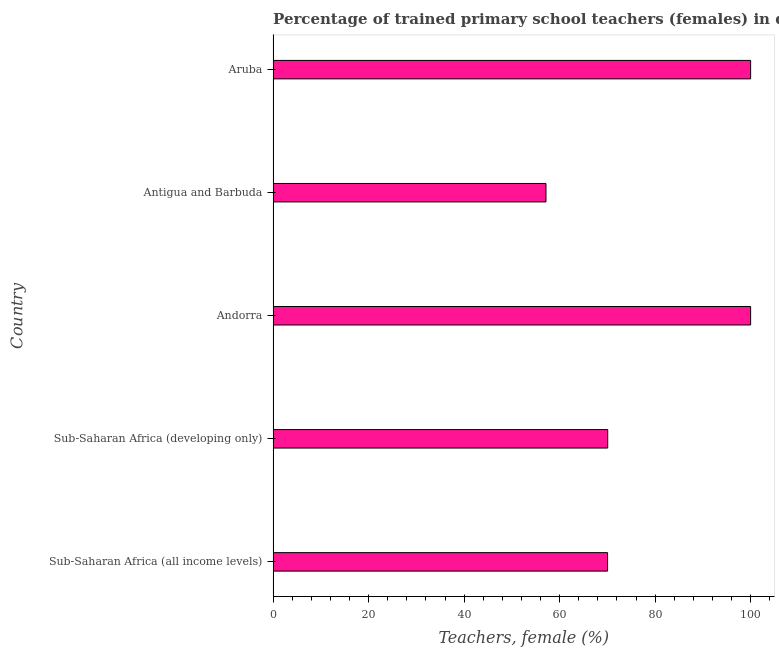Does the graph contain grids?
Provide a short and direct response. No. What is the title of the graph?
Your answer should be very brief. Percentage of trained primary school teachers (females) in different countries. What is the label or title of the X-axis?
Provide a succinct answer. Teachers, female (%). What is the percentage of trained female teachers in Aruba?
Your answer should be very brief. 100. Across all countries, what is the maximum percentage of trained female teachers?
Give a very brief answer. 100. Across all countries, what is the minimum percentage of trained female teachers?
Offer a terse response. 57.14. In which country was the percentage of trained female teachers maximum?
Your answer should be very brief. Andorra. In which country was the percentage of trained female teachers minimum?
Your answer should be compact. Antigua and Barbuda. What is the sum of the percentage of trained female teachers?
Give a very brief answer. 397.26. What is the difference between the percentage of trained female teachers in Aruba and Sub-Saharan Africa (all income levels)?
Make the answer very short. 29.95. What is the average percentage of trained female teachers per country?
Offer a terse response. 79.45. What is the median percentage of trained female teachers?
Ensure brevity in your answer.  70.07. What is the ratio of the percentage of trained female teachers in Aruba to that in Sub-Saharan Africa (all income levels)?
Your answer should be very brief. 1.43. Is the difference between the percentage of trained female teachers in Antigua and Barbuda and Sub-Saharan Africa (all income levels) greater than the difference between any two countries?
Provide a succinct answer. No. What is the difference between the highest and the lowest percentage of trained female teachers?
Your answer should be very brief. 42.86. How many countries are there in the graph?
Your answer should be very brief. 5. What is the difference between two consecutive major ticks on the X-axis?
Provide a short and direct response. 20. Are the values on the major ticks of X-axis written in scientific E-notation?
Keep it short and to the point. No. What is the Teachers, female (%) in Sub-Saharan Africa (all income levels)?
Provide a succinct answer. 70.05. What is the Teachers, female (%) in Sub-Saharan Africa (developing only)?
Your answer should be compact. 70.07. What is the Teachers, female (%) in Andorra?
Offer a terse response. 100. What is the Teachers, female (%) of Antigua and Barbuda?
Ensure brevity in your answer.  57.14. What is the Teachers, female (%) in Aruba?
Offer a very short reply. 100. What is the difference between the Teachers, female (%) in Sub-Saharan Africa (all income levels) and Sub-Saharan Africa (developing only)?
Your answer should be very brief. -0.03. What is the difference between the Teachers, female (%) in Sub-Saharan Africa (all income levels) and Andorra?
Keep it short and to the point. -29.95. What is the difference between the Teachers, female (%) in Sub-Saharan Africa (all income levels) and Antigua and Barbuda?
Give a very brief answer. 12.9. What is the difference between the Teachers, female (%) in Sub-Saharan Africa (all income levels) and Aruba?
Make the answer very short. -29.95. What is the difference between the Teachers, female (%) in Sub-Saharan Africa (developing only) and Andorra?
Give a very brief answer. -29.93. What is the difference between the Teachers, female (%) in Sub-Saharan Africa (developing only) and Antigua and Barbuda?
Your response must be concise. 12.93. What is the difference between the Teachers, female (%) in Sub-Saharan Africa (developing only) and Aruba?
Provide a succinct answer. -29.93. What is the difference between the Teachers, female (%) in Andorra and Antigua and Barbuda?
Offer a terse response. 42.86. What is the difference between the Teachers, female (%) in Andorra and Aruba?
Your answer should be very brief. 0. What is the difference between the Teachers, female (%) in Antigua and Barbuda and Aruba?
Offer a terse response. -42.86. What is the ratio of the Teachers, female (%) in Sub-Saharan Africa (all income levels) to that in Antigua and Barbuda?
Ensure brevity in your answer.  1.23. What is the ratio of the Teachers, female (%) in Sub-Saharan Africa (all income levels) to that in Aruba?
Give a very brief answer. 0.7. What is the ratio of the Teachers, female (%) in Sub-Saharan Africa (developing only) to that in Andorra?
Give a very brief answer. 0.7. What is the ratio of the Teachers, female (%) in Sub-Saharan Africa (developing only) to that in Antigua and Barbuda?
Make the answer very short. 1.23. What is the ratio of the Teachers, female (%) in Sub-Saharan Africa (developing only) to that in Aruba?
Offer a very short reply. 0.7. What is the ratio of the Teachers, female (%) in Andorra to that in Aruba?
Ensure brevity in your answer.  1. What is the ratio of the Teachers, female (%) in Antigua and Barbuda to that in Aruba?
Your answer should be very brief. 0.57. 